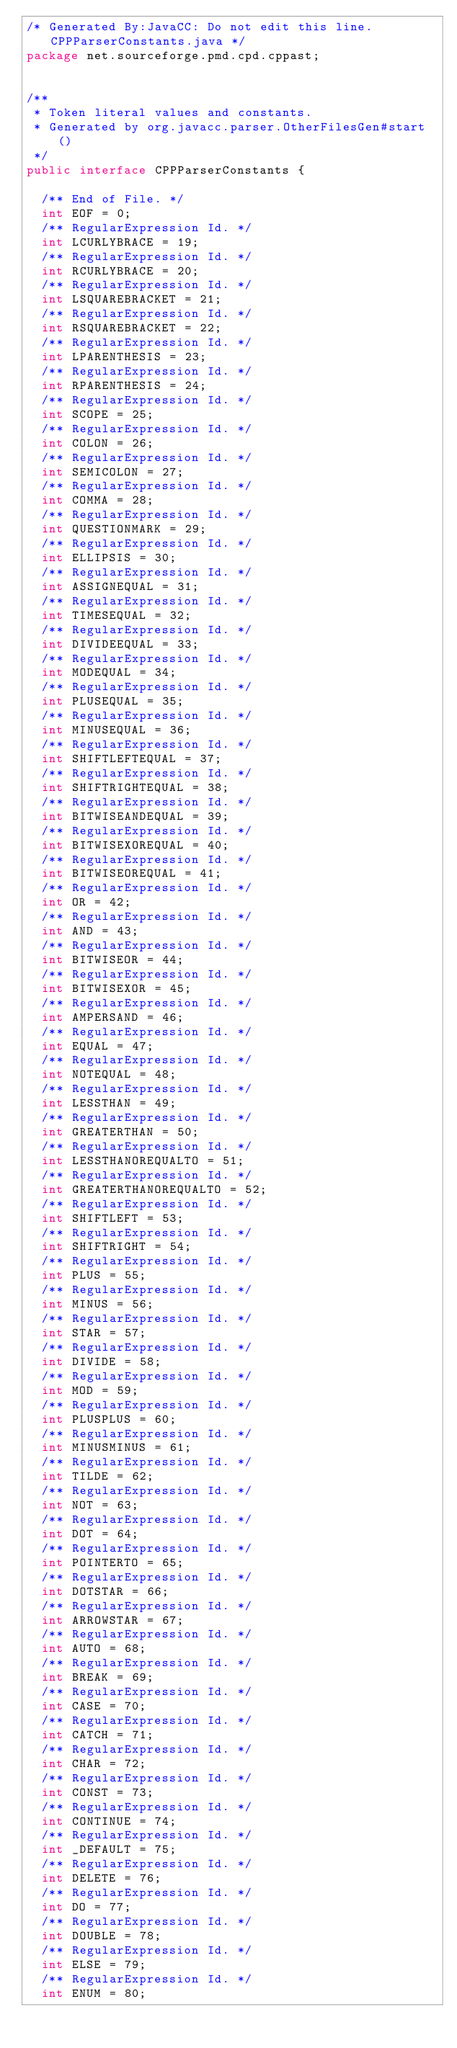<code> <loc_0><loc_0><loc_500><loc_500><_Java_>/* Generated By:JavaCC: Do not edit this line. CPPParserConstants.java */
package net.sourceforge.pmd.cpd.cppast;


/**
 * Token literal values and constants.
 * Generated by org.javacc.parser.OtherFilesGen#start()
 */
public interface CPPParserConstants {

  /** End of File. */
  int EOF = 0;
  /** RegularExpression Id. */
  int LCURLYBRACE = 19;
  /** RegularExpression Id. */
  int RCURLYBRACE = 20;
  /** RegularExpression Id. */
  int LSQUAREBRACKET = 21;
  /** RegularExpression Id. */
  int RSQUAREBRACKET = 22;
  /** RegularExpression Id. */
  int LPARENTHESIS = 23;
  /** RegularExpression Id. */
  int RPARENTHESIS = 24;
  /** RegularExpression Id. */
  int SCOPE = 25;
  /** RegularExpression Id. */
  int COLON = 26;
  /** RegularExpression Id. */
  int SEMICOLON = 27;
  /** RegularExpression Id. */
  int COMMA = 28;
  /** RegularExpression Id. */
  int QUESTIONMARK = 29;
  /** RegularExpression Id. */
  int ELLIPSIS = 30;
  /** RegularExpression Id. */
  int ASSIGNEQUAL = 31;
  /** RegularExpression Id. */
  int TIMESEQUAL = 32;
  /** RegularExpression Id. */
  int DIVIDEEQUAL = 33;
  /** RegularExpression Id. */
  int MODEQUAL = 34;
  /** RegularExpression Id. */
  int PLUSEQUAL = 35;
  /** RegularExpression Id. */
  int MINUSEQUAL = 36;
  /** RegularExpression Id. */
  int SHIFTLEFTEQUAL = 37;
  /** RegularExpression Id. */
  int SHIFTRIGHTEQUAL = 38;
  /** RegularExpression Id. */
  int BITWISEANDEQUAL = 39;
  /** RegularExpression Id. */
  int BITWISEXOREQUAL = 40;
  /** RegularExpression Id. */
  int BITWISEOREQUAL = 41;
  /** RegularExpression Id. */
  int OR = 42;
  /** RegularExpression Id. */
  int AND = 43;
  /** RegularExpression Id. */
  int BITWISEOR = 44;
  /** RegularExpression Id. */
  int BITWISEXOR = 45;
  /** RegularExpression Id. */
  int AMPERSAND = 46;
  /** RegularExpression Id. */
  int EQUAL = 47;
  /** RegularExpression Id. */
  int NOTEQUAL = 48;
  /** RegularExpression Id. */
  int LESSTHAN = 49;
  /** RegularExpression Id. */
  int GREATERTHAN = 50;
  /** RegularExpression Id. */
  int LESSTHANOREQUALTO = 51;
  /** RegularExpression Id. */
  int GREATERTHANOREQUALTO = 52;
  /** RegularExpression Id. */
  int SHIFTLEFT = 53;
  /** RegularExpression Id. */
  int SHIFTRIGHT = 54;
  /** RegularExpression Id. */
  int PLUS = 55;
  /** RegularExpression Id. */
  int MINUS = 56;
  /** RegularExpression Id. */
  int STAR = 57;
  /** RegularExpression Id. */
  int DIVIDE = 58;
  /** RegularExpression Id. */
  int MOD = 59;
  /** RegularExpression Id. */
  int PLUSPLUS = 60;
  /** RegularExpression Id. */
  int MINUSMINUS = 61;
  /** RegularExpression Id. */
  int TILDE = 62;
  /** RegularExpression Id. */
  int NOT = 63;
  /** RegularExpression Id. */
  int DOT = 64;
  /** RegularExpression Id. */
  int POINTERTO = 65;
  /** RegularExpression Id. */
  int DOTSTAR = 66;
  /** RegularExpression Id. */
  int ARROWSTAR = 67;
  /** RegularExpression Id. */
  int AUTO = 68;
  /** RegularExpression Id. */
  int BREAK = 69;
  /** RegularExpression Id. */
  int CASE = 70;
  /** RegularExpression Id. */
  int CATCH = 71;
  /** RegularExpression Id. */
  int CHAR = 72;
  /** RegularExpression Id. */
  int CONST = 73;
  /** RegularExpression Id. */
  int CONTINUE = 74;
  /** RegularExpression Id. */
  int _DEFAULT = 75;
  /** RegularExpression Id. */
  int DELETE = 76;
  /** RegularExpression Id. */
  int DO = 77;
  /** RegularExpression Id. */
  int DOUBLE = 78;
  /** RegularExpression Id. */
  int ELSE = 79;
  /** RegularExpression Id. */
  int ENUM = 80;</code> 